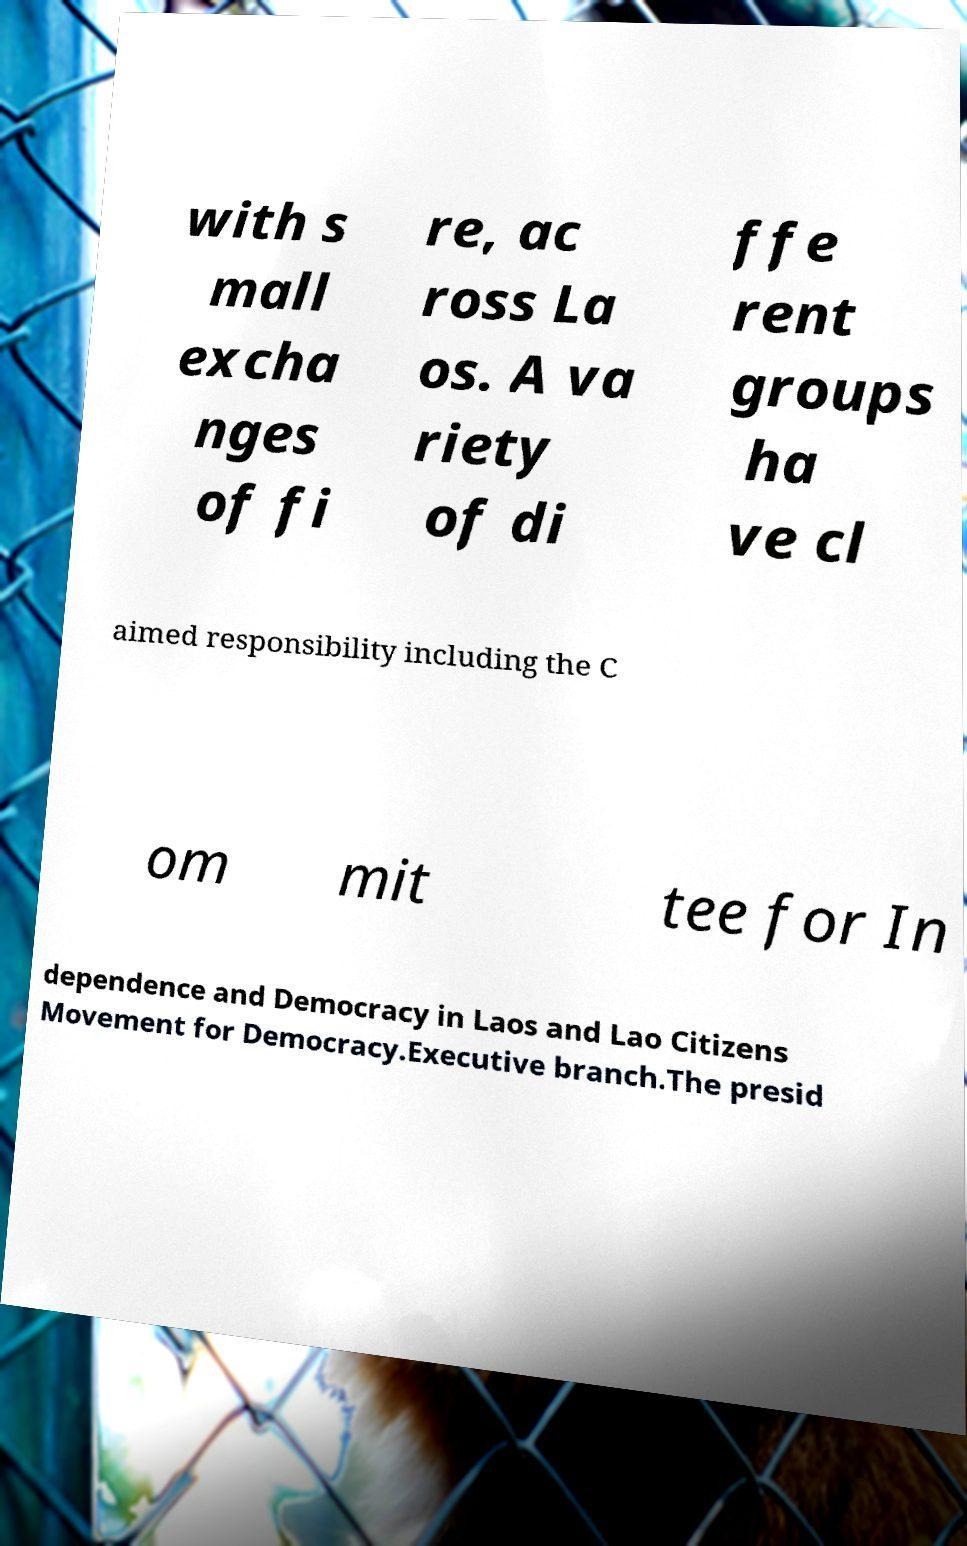For documentation purposes, I need the text within this image transcribed. Could you provide that? with s mall excha nges of fi re, ac ross La os. A va riety of di ffe rent groups ha ve cl aimed responsibility including the C om mit tee for In dependence and Democracy in Laos and Lao Citizens Movement for Democracy.Executive branch.The presid 